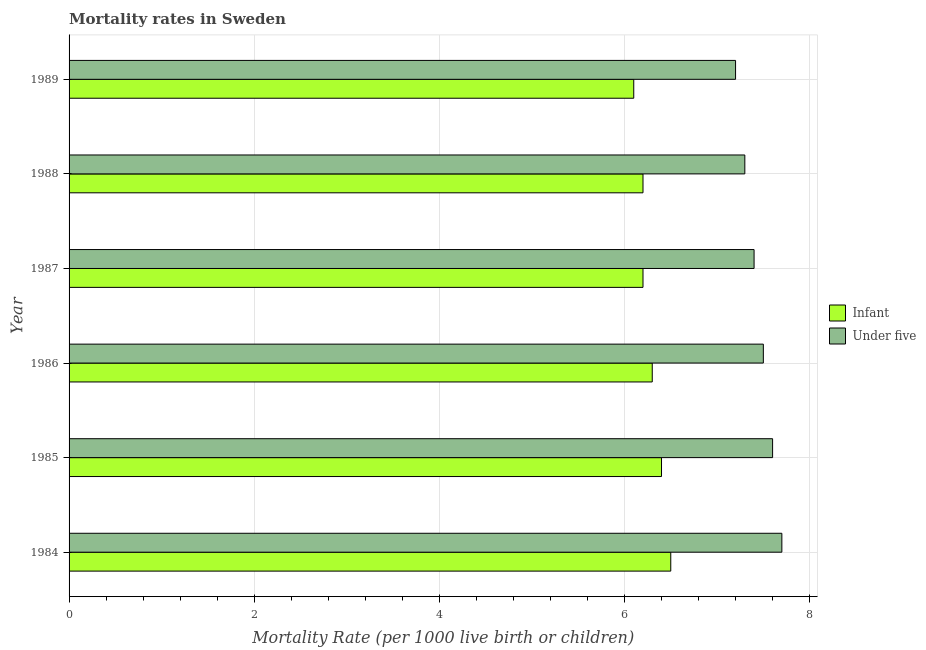How many bars are there on the 6th tick from the top?
Provide a short and direct response. 2. Across all years, what is the minimum infant mortality rate?
Your answer should be compact. 6.1. What is the total infant mortality rate in the graph?
Offer a terse response. 37.7. What is the difference between the infant mortality rate in 1984 and the under-5 mortality rate in 1987?
Your answer should be very brief. -0.9. What is the average under-5 mortality rate per year?
Ensure brevity in your answer.  7.45. In the year 1986, what is the difference between the infant mortality rate and under-5 mortality rate?
Provide a short and direct response. -1.2. What is the difference between the highest and the second highest under-5 mortality rate?
Your response must be concise. 0.1. In how many years, is the infant mortality rate greater than the average infant mortality rate taken over all years?
Your answer should be very brief. 3. Is the sum of the under-5 mortality rate in 1986 and 1988 greater than the maximum infant mortality rate across all years?
Give a very brief answer. Yes. What does the 1st bar from the top in 1988 represents?
Ensure brevity in your answer.  Under five. What does the 1st bar from the bottom in 1989 represents?
Provide a short and direct response. Infant. How many years are there in the graph?
Offer a terse response. 6. Does the graph contain grids?
Give a very brief answer. Yes. Where does the legend appear in the graph?
Provide a succinct answer. Center right. How many legend labels are there?
Provide a succinct answer. 2. How are the legend labels stacked?
Keep it short and to the point. Vertical. What is the title of the graph?
Provide a succinct answer. Mortality rates in Sweden. What is the label or title of the X-axis?
Your answer should be very brief. Mortality Rate (per 1000 live birth or children). What is the Mortality Rate (per 1000 live birth or children) in Infant in 1984?
Make the answer very short. 6.5. What is the Mortality Rate (per 1000 live birth or children) in Infant in 1985?
Provide a short and direct response. 6.4. What is the Mortality Rate (per 1000 live birth or children) in Infant in 1987?
Your response must be concise. 6.2. What is the Mortality Rate (per 1000 live birth or children) of Under five in 1987?
Provide a succinct answer. 7.4. What is the Mortality Rate (per 1000 live birth or children) of Under five in 1988?
Provide a short and direct response. 7.3. Across all years, what is the maximum Mortality Rate (per 1000 live birth or children) of Under five?
Provide a succinct answer. 7.7. What is the total Mortality Rate (per 1000 live birth or children) of Infant in the graph?
Your answer should be compact. 37.7. What is the total Mortality Rate (per 1000 live birth or children) of Under five in the graph?
Give a very brief answer. 44.7. What is the difference between the Mortality Rate (per 1000 live birth or children) of Infant in 1984 and that in 1985?
Provide a short and direct response. 0.1. What is the difference between the Mortality Rate (per 1000 live birth or children) of Under five in 1984 and that in 1985?
Offer a very short reply. 0.1. What is the difference between the Mortality Rate (per 1000 live birth or children) of Infant in 1984 and that in 1986?
Keep it short and to the point. 0.2. What is the difference between the Mortality Rate (per 1000 live birth or children) of Under five in 1984 and that in 1986?
Your response must be concise. 0.2. What is the difference between the Mortality Rate (per 1000 live birth or children) in Infant in 1984 and that in 1987?
Offer a terse response. 0.3. What is the difference between the Mortality Rate (per 1000 live birth or children) of Infant in 1984 and that in 1988?
Provide a short and direct response. 0.3. What is the difference between the Mortality Rate (per 1000 live birth or children) of Infant in 1984 and that in 1989?
Make the answer very short. 0.4. What is the difference between the Mortality Rate (per 1000 live birth or children) in Under five in 1984 and that in 1989?
Keep it short and to the point. 0.5. What is the difference between the Mortality Rate (per 1000 live birth or children) in Infant in 1985 and that in 1987?
Your response must be concise. 0.2. What is the difference between the Mortality Rate (per 1000 live birth or children) of Under five in 1985 and that in 1988?
Your response must be concise. 0.3. What is the difference between the Mortality Rate (per 1000 live birth or children) in Infant in 1986 and that in 1987?
Your response must be concise. 0.1. What is the difference between the Mortality Rate (per 1000 live birth or children) in Infant in 1986 and that in 1988?
Provide a succinct answer. 0.1. What is the difference between the Mortality Rate (per 1000 live birth or children) of Under five in 1986 and that in 1989?
Ensure brevity in your answer.  0.3. What is the difference between the Mortality Rate (per 1000 live birth or children) of Infant in 1987 and that in 1988?
Ensure brevity in your answer.  0. What is the difference between the Mortality Rate (per 1000 live birth or children) in Under five in 1987 and that in 1988?
Your answer should be very brief. 0.1. What is the difference between the Mortality Rate (per 1000 live birth or children) in Infant in 1987 and that in 1989?
Your response must be concise. 0.1. What is the difference between the Mortality Rate (per 1000 live birth or children) of Infant in 1984 and the Mortality Rate (per 1000 live birth or children) of Under five in 1986?
Provide a succinct answer. -1. What is the difference between the Mortality Rate (per 1000 live birth or children) in Infant in 1984 and the Mortality Rate (per 1000 live birth or children) in Under five in 1988?
Give a very brief answer. -0.8. What is the difference between the Mortality Rate (per 1000 live birth or children) of Infant in 1984 and the Mortality Rate (per 1000 live birth or children) of Under five in 1989?
Provide a short and direct response. -0.7. What is the difference between the Mortality Rate (per 1000 live birth or children) in Infant in 1985 and the Mortality Rate (per 1000 live birth or children) in Under five in 1986?
Provide a short and direct response. -1.1. What is the difference between the Mortality Rate (per 1000 live birth or children) in Infant in 1985 and the Mortality Rate (per 1000 live birth or children) in Under five in 1987?
Your answer should be compact. -1. What is the difference between the Mortality Rate (per 1000 live birth or children) of Infant in 1985 and the Mortality Rate (per 1000 live birth or children) of Under five in 1988?
Provide a short and direct response. -0.9. What is the difference between the Mortality Rate (per 1000 live birth or children) in Infant in 1985 and the Mortality Rate (per 1000 live birth or children) in Under five in 1989?
Give a very brief answer. -0.8. What is the difference between the Mortality Rate (per 1000 live birth or children) of Infant in 1986 and the Mortality Rate (per 1000 live birth or children) of Under five in 1987?
Your answer should be very brief. -1.1. What is the difference between the Mortality Rate (per 1000 live birth or children) of Infant in 1987 and the Mortality Rate (per 1000 live birth or children) of Under five in 1988?
Make the answer very short. -1.1. What is the difference between the Mortality Rate (per 1000 live birth or children) of Infant in 1987 and the Mortality Rate (per 1000 live birth or children) of Under five in 1989?
Your response must be concise. -1. What is the average Mortality Rate (per 1000 live birth or children) of Infant per year?
Make the answer very short. 6.28. What is the average Mortality Rate (per 1000 live birth or children) in Under five per year?
Make the answer very short. 7.45. In the year 1984, what is the difference between the Mortality Rate (per 1000 live birth or children) in Infant and Mortality Rate (per 1000 live birth or children) in Under five?
Keep it short and to the point. -1.2. In the year 1986, what is the difference between the Mortality Rate (per 1000 live birth or children) in Infant and Mortality Rate (per 1000 live birth or children) in Under five?
Offer a very short reply. -1.2. In the year 1987, what is the difference between the Mortality Rate (per 1000 live birth or children) of Infant and Mortality Rate (per 1000 live birth or children) of Under five?
Keep it short and to the point. -1.2. In the year 1988, what is the difference between the Mortality Rate (per 1000 live birth or children) in Infant and Mortality Rate (per 1000 live birth or children) in Under five?
Provide a succinct answer. -1.1. In the year 1989, what is the difference between the Mortality Rate (per 1000 live birth or children) of Infant and Mortality Rate (per 1000 live birth or children) of Under five?
Provide a succinct answer. -1.1. What is the ratio of the Mortality Rate (per 1000 live birth or children) in Infant in 1984 to that in 1985?
Your answer should be very brief. 1.02. What is the ratio of the Mortality Rate (per 1000 live birth or children) of Under five in 1984 to that in 1985?
Your response must be concise. 1.01. What is the ratio of the Mortality Rate (per 1000 live birth or children) of Infant in 1984 to that in 1986?
Give a very brief answer. 1.03. What is the ratio of the Mortality Rate (per 1000 live birth or children) of Under five in 1984 to that in 1986?
Provide a succinct answer. 1.03. What is the ratio of the Mortality Rate (per 1000 live birth or children) in Infant in 1984 to that in 1987?
Ensure brevity in your answer.  1.05. What is the ratio of the Mortality Rate (per 1000 live birth or children) in Under five in 1984 to that in 1987?
Make the answer very short. 1.04. What is the ratio of the Mortality Rate (per 1000 live birth or children) in Infant in 1984 to that in 1988?
Make the answer very short. 1.05. What is the ratio of the Mortality Rate (per 1000 live birth or children) in Under five in 1984 to that in 1988?
Keep it short and to the point. 1.05. What is the ratio of the Mortality Rate (per 1000 live birth or children) in Infant in 1984 to that in 1989?
Your response must be concise. 1.07. What is the ratio of the Mortality Rate (per 1000 live birth or children) of Under five in 1984 to that in 1989?
Your answer should be very brief. 1.07. What is the ratio of the Mortality Rate (per 1000 live birth or children) of Infant in 1985 to that in 1986?
Provide a succinct answer. 1.02. What is the ratio of the Mortality Rate (per 1000 live birth or children) in Under five in 1985 to that in 1986?
Provide a succinct answer. 1.01. What is the ratio of the Mortality Rate (per 1000 live birth or children) in Infant in 1985 to that in 1987?
Ensure brevity in your answer.  1.03. What is the ratio of the Mortality Rate (per 1000 live birth or children) in Under five in 1985 to that in 1987?
Your answer should be compact. 1.03. What is the ratio of the Mortality Rate (per 1000 live birth or children) of Infant in 1985 to that in 1988?
Your answer should be very brief. 1.03. What is the ratio of the Mortality Rate (per 1000 live birth or children) of Under five in 1985 to that in 1988?
Make the answer very short. 1.04. What is the ratio of the Mortality Rate (per 1000 live birth or children) in Infant in 1985 to that in 1989?
Make the answer very short. 1.05. What is the ratio of the Mortality Rate (per 1000 live birth or children) of Under five in 1985 to that in 1989?
Provide a short and direct response. 1.06. What is the ratio of the Mortality Rate (per 1000 live birth or children) in Infant in 1986 to that in 1987?
Make the answer very short. 1.02. What is the ratio of the Mortality Rate (per 1000 live birth or children) of Under five in 1986 to that in 1987?
Keep it short and to the point. 1.01. What is the ratio of the Mortality Rate (per 1000 live birth or children) in Infant in 1986 to that in 1988?
Your answer should be very brief. 1.02. What is the ratio of the Mortality Rate (per 1000 live birth or children) in Under five in 1986 to that in 1988?
Keep it short and to the point. 1.03. What is the ratio of the Mortality Rate (per 1000 live birth or children) of Infant in 1986 to that in 1989?
Your answer should be very brief. 1.03. What is the ratio of the Mortality Rate (per 1000 live birth or children) in Under five in 1986 to that in 1989?
Your answer should be very brief. 1.04. What is the ratio of the Mortality Rate (per 1000 live birth or children) in Infant in 1987 to that in 1988?
Your response must be concise. 1. What is the ratio of the Mortality Rate (per 1000 live birth or children) in Under five in 1987 to that in 1988?
Give a very brief answer. 1.01. What is the ratio of the Mortality Rate (per 1000 live birth or children) in Infant in 1987 to that in 1989?
Provide a succinct answer. 1.02. What is the ratio of the Mortality Rate (per 1000 live birth or children) of Under five in 1987 to that in 1989?
Provide a succinct answer. 1.03. What is the ratio of the Mortality Rate (per 1000 live birth or children) of Infant in 1988 to that in 1989?
Provide a succinct answer. 1.02. What is the ratio of the Mortality Rate (per 1000 live birth or children) of Under five in 1988 to that in 1989?
Offer a terse response. 1.01. What is the difference between the highest and the second highest Mortality Rate (per 1000 live birth or children) in Infant?
Give a very brief answer. 0.1. What is the difference between the highest and the lowest Mortality Rate (per 1000 live birth or children) in Infant?
Provide a short and direct response. 0.4. What is the difference between the highest and the lowest Mortality Rate (per 1000 live birth or children) in Under five?
Offer a very short reply. 0.5. 